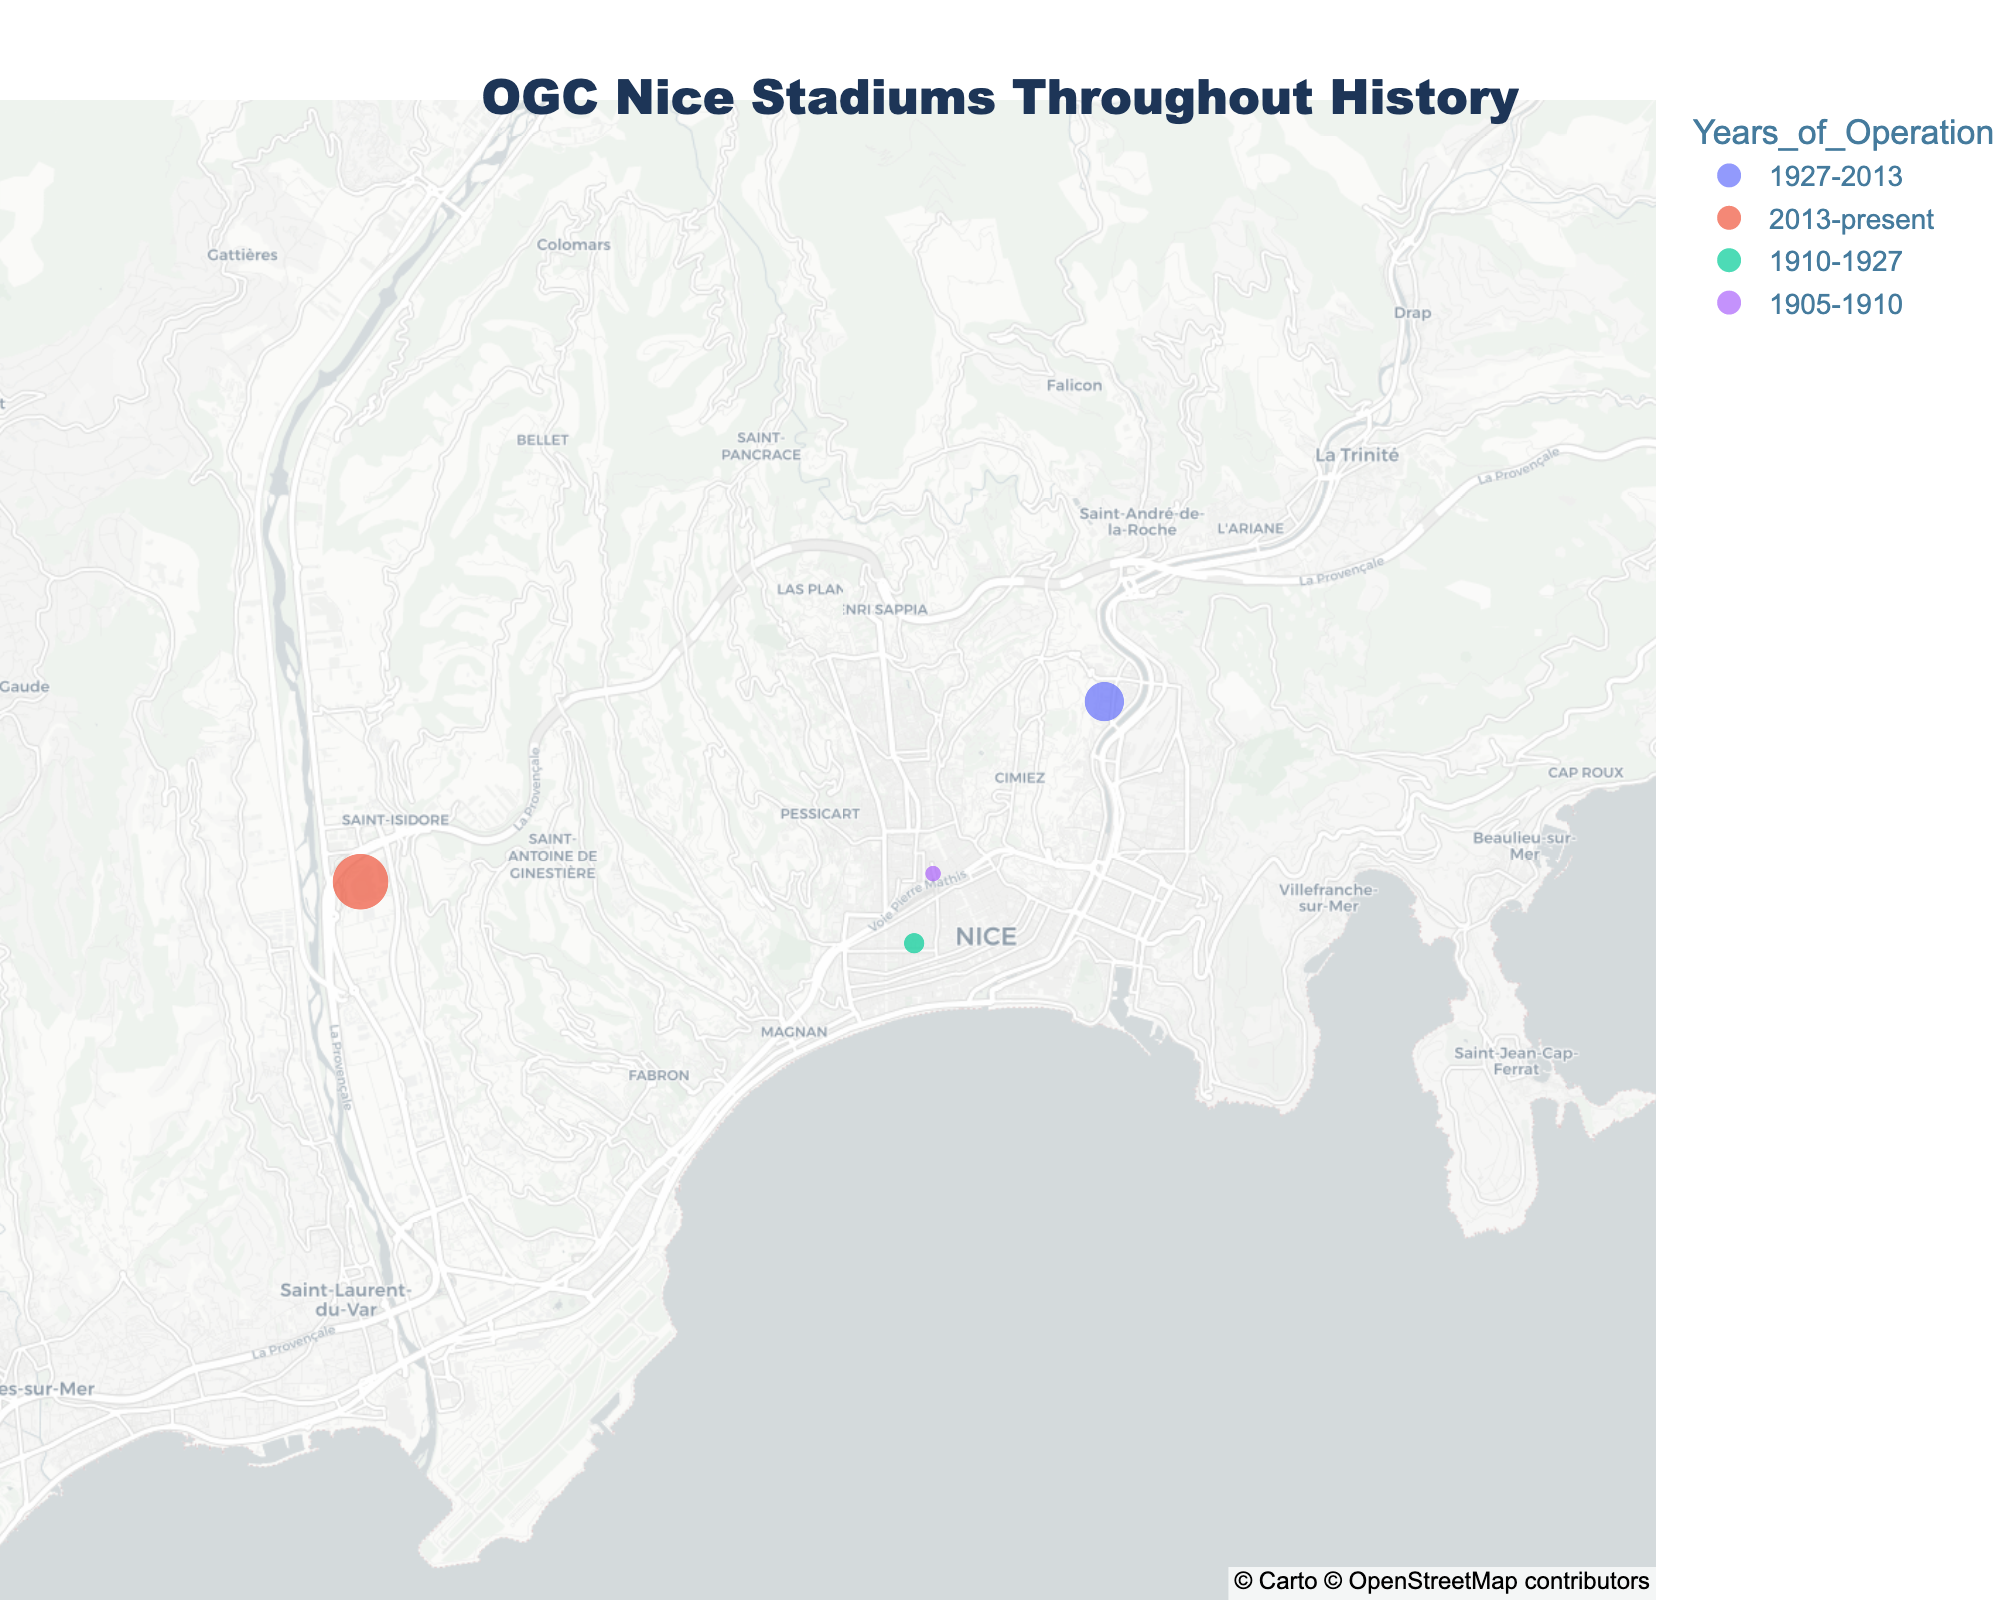How many stadiums have been used by OGC Nice throughout its history? By counting the number of points (stadiums) shown on the map, you can see there are four distinct locations listed in the dataset.
Answer: Four Which stadium has the highest capacity? From the figure, you can hover over the points to see the capacity. The Allianz Riviera has the largest size indicator on the map and shows a capacity of 35,624 in the hover information.
Answer: Allianz Riviera When did OGC Nice start using the Allianz Riviera? According to the hover information on the Allianz Riviera marker, the years of operation start from 2013 to present.
Answer: 2013 Which stadium had the shortest period of operation? By reviewing the years of operation for each stadium, Stade Saint-Maurice operated from 1905 to 1910, which is only 5 years.
Answer: Stade Saint-Maurice What is the approximate latitude of Stade du Ray? Hover over the Stade du Ray marker to see the coordinate information; it has a latitude of approximately 43.7214.
Answer: 43.7214 Compare the capacities of Stade du Ray and Stade Léo-Lagrange. Which one is larger? By hovering over each respective marker on the map, Stade du Ray has a capacity of 18,000, while Stade Léo-Lagrange has 5,000. Therefore, Stade du Ray is larger in capacity.
Answer: Stade du Ray What is the aggregate capacity of all the stadiums? Sum the capacities from each stadium: 18,000 (Stade du Ray) + 35,624 (Allianz Riviera) + 5,000 (Stade Léo-Lagrange) + 3,000 (Stade Saint-Maurice) = 61,624.
Answer: 61,624 Which stadium was in use right before the Allianz Riviera? By analyzing the years of operation, Stade du Ray was in use until 2013, which overlaps with the beginning of Allianz Riviera's operation.
Answer: Stade du Ray What is the geographic distance between Stade du Ray and Allianz Riviera? Using the latitude and longitude for Stade du Ray (43.7214, 7.2828) and Allianz Riviera (43.7056, 7.1925), you could calculate the geographic distance but note it's not directly visible on the map.
Answer: Not directly visible Which stadium was used for only 17 years? Reviewing the years of operation for each stadium, Stade Léo-Lagrange was used from 1910-1927, which constitutes 17 years.
Answer: Stade Léo-Lagrange 